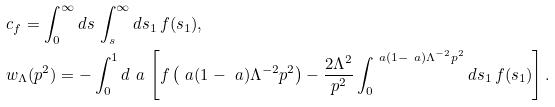<formula> <loc_0><loc_0><loc_500><loc_500>& c _ { f } = \int _ { 0 } ^ { \infty } d s \, \int _ { s } ^ { \infty } d s _ { 1 } \, f ( s _ { 1 } ) , \\ & w _ { \Lambda } ( p ^ { 2 } ) = - \int _ { 0 } ^ { 1 } d \ a \, \left [ f \left ( \ a ( 1 - \ a ) \Lambda ^ { - 2 } p ^ { 2 } \right ) - \frac { 2 \Lambda ^ { 2 } } { p ^ { 2 } } \int ^ { \ a ( 1 - \ a ) \Lambda ^ { - 2 } p ^ { 2 } } _ { 0 } d s _ { 1 } \, f ( s _ { 1 } ) \right ] .</formula> 